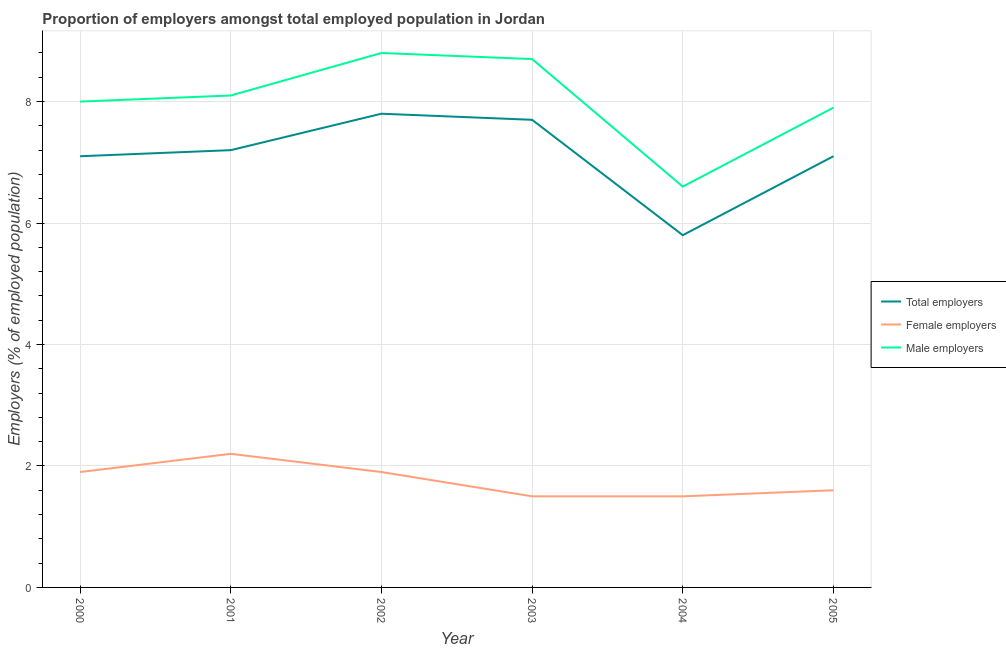Is the number of lines equal to the number of legend labels?
Ensure brevity in your answer.  Yes. What is the percentage of male employers in 2001?
Provide a short and direct response. 8.1. Across all years, what is the maximum percentage of male employers?
Offer a terse response. 8.8. Across all years, what is the minimum percentage of total employers?
Your answer should be very brief. 5.8. In which year was the percentage of total employers minimum?
Offer a very short reply. 2004. What is the total percentage of total employers in the graph?
Keep it short and to the point. 42.7. What is the difference between the percentage of total employers in 2000 and the percentage of male employers in 2003?
Ensure brevity in your answer.  -1.6. What is the average percentage of male employers per year?
Your response must be concise. 8.02. In the year 2004, what is the difference between the percentage of female employers and percentage of male employers?
Your answer should be very brief. -5.1. What is the ratio of the percentage of female employers in 2002 to that in 2003?
Give a very brief answer. 1.27. What is the difference between the highest and the second highest percentage of male employers?
Provide a short and direct response. 0.1. What is the difference between the highest and the lowest percentage of female employers?
Your response must be concise. 0.7. Is it the case that in every year, the sum of the percentage of total employers and percentage of female employers is greater than the percentage of male employers?
Offer a terse response. Yes. Does the percentage of total employers monotonically increase over the years?
Your response must be concise. No. Is the percentage of female employers strictly less than the percentage of total employers over the years?
Offer a terse response. Yes. How many lines are there?
Offer a very short reply. 3. Does the graph contain any zero values?
Your answer should be very brief. No. How many legend labels are there?
Ensure brevity in your answer.  3. What is the title of the graph?
Make the answer very short. Proportion of employers amongst total employed population in Jordan. What is the label or title of the X-axis?
Your answer should be very brief. Year. What is the label or title of the Y-axis?
Your answer should be very brief. Employers (% of employed population). What is the Employers (% of employed population) in Total employers in 2000?
Offer a terse response. 7.1. What is the Employers (% of employed population) of Female employers in 2000?
Offer a terse response. 1.9. What is the Employers (% of employed population) in Total employers in 2001?
Offer a very short reply. 7.2. What is the Employers (% of employed population) of Female employers in 2001?
Your response must be concise. 2.2. What is the Employers (% of employed population) in Male employers in 2001?
Give a very brief answer. 8.1. What is the Employers (% of employed population) of Total employers in 2002?
Your answer should be compact. 7.8. What is the Employers (% of employed population) in Female employers in 2002?
Provide a succinct answer. 1.9. What is the Employers (% of employed population) in Male employers in 2002?
Offer a terse response. 8.8. What is the Employers (% of employed population) in Total employers in 2003?
Your answer should be compact. 7.7. What is the Employers (% of employed population) of Male employers in 2003?
Provide a short and direct response. 8.7. What is the Employers (% of employed population) in Total employers in 2004?
Provide a succinct answer. 5.8. What is the Employers (% of employed population) in Male employers in 2004?
Your response must be concise. 6.6. What is the Employers (% of employed population) of Total employers in 2005?
Your answer should be compact. 7.1. What is the Employers (% of employed population) of Female employers in 2005?
Offer a very short reply. 1.6. What is the Employers (% of employed population) of Male employers in 2005?
Offer a terse response. 7.9. Across all years, what is the maximum Employers (% of employed population) of Total employers?
Offer a terse response. 7.8. Across all years, what is the maximum Employers (% of employed population) in Female employers?
Make the answer very short. 2.2. Across all years, what is the maximum Employers (% of employed population) of Male employers?
Provide a short and direct response. 8.8. Across all years, what is the minimum Employers (% of employed population) of Total employers?
Your answer should be very brief. 5.8. Across all years, what is the minimum Employers (% of employed population) in Female employers?
Ensure brevity in your answer.  1.5. Across all years, what is the minimum Employers (% of employed population) of Male employers?
Keep it short and to the point. 6.6. What is the total Employers (% of employed population) in Total employers in the graph?
Keep it short and to the point. 42.7. What is the total Employers (% of employed population) of Female employers in the graph?
Your answer should be very brief. 10.6. What is the total Employers (% of employed population) of Male employers in the graph?
Give a very brief answer. 48.1. What is the difference between the Employers (% of employed population) of Female employers in 2000 and that in 2001?
Your answer should be compact. -0.3. What is the difference between the Employers (% of employed population) in Male employers in 2000 and that in 2001?
Give a very brief answer. -0.1. What is the difference between the Employers (% of employed population) in Female employers in 2000 and that in 2002?
Ensure brevity in your answer.  0. What is the difference between the Employers (% of employed population) in Female employers in 2000 and that in 2003?
Provide a short and direct response. 0.4. What is the difference between the Employers (% of employed population) in Total employers in 2000 and that in 2004?
Provide a short and direct response. 1.3. What is the difference between the Employers (% of employed population) of Male employers in 2000 and that in 2004?
Provide a short and direct response. 1.4. What is the difference between the Employers (% of employed population) in Total employers in 2000 and that in 2005?
Offer a terse response. 0. What is the difference between the Employers (% of employed population) of Female employers in 2000 and that in 2005?
Give a very brief answer. 0.3. What is the difference between the Employers (% of employed population) of Male employers in 2000 and that in 2005?
Provide a succinct answer. 0.1. What is the difference between the Employers (% of employed population) of Total employers in 2001 and that in 2002?
Provide a succinct answer. -0.6. What is the difference between the Employers (% of employed population) of Female employers in 2001 and that in 2002?
Provide a short and direct response. 0.3. What is the difference between the Employers (% of employed population) of Total employers in 2001 and that in 2003?
Provide a short and direct response. -0.5. What is the difference between the Employers (% of employed population) of Female employers in 2001 and that in 2003?
Ensure brevity in your answer.  0.7. What is the difference between the Employers (% of employed population) of Total employers in 2001 and that in 2004?
Give a very brief answer. 1.4. What is the difference between the Employers (% of employed population) in Female employers in 2001 and that in 2004?
Give a very brief answer. 0.7. What is the difference between the Employers (% of employed population) of Total employers in 2001 and that in 2005?
Offer a very short reply. 0.1. What is the difference between the Employers (% of employed population) of Female employers in 2002 and that in 2003?
Offer a terse response. 0.4. What is the difference between the Employers (% of employed population) of Female employers in 2002 and that in 2004?
Keep it short and to the point. 0.4. What is the difference between the Employers (% of employed population) of Male employers in 2002 and that in 2004?
Give a very brief answer. 2.2. What is the difference between the Employers (% of employed population) of Female employers in 2002 and that in 2005?
Your response must be concise. 0.3. What is the difference between the Employers (% of employed population) of Total employers in 2003 and that in 2004?
Make the answer very short. 1.9. What is the difference between the Employers (% of employed population) in Male employers in 2003 and that in 2004?
Provide a short and direct response. 2.1. What is the difference between the Employers (% of employed population) of Male employers in 2003 and that in 2005?
Provide a short and direct response. 0.8. What is the difference between the Employers (% of employed population) in Total employers in 2000 and the Employers (% of employed population) in Male employers in 2001?
Offer a very short reply. -1. What is the difference between the Employers (% of employed population) of Total employers in 2000 and the Employers (% of employed population) of Female employers in 2002?
Ensure brevity in your answer.  5.2. What is the difference between the Employers (% of employed population) in Total employers in 2000 and the Employers (% of employed population) in Male employers in 2002?
Keep it short and to the point. -1.7. What is the difference between the Employers (% of employed population) of Female employers in 2000 and the Employers (% of employed population) of Male employers in 2002?
Offer a terse response. -6.9. What is the difference between the Employers (% of employed population) of Total employers in 2000 and the Employers (% of employed population) of Female employers in 2003?
Make the answer very short. 5.6. What is the difference between the Employers (% of employed population) in Total employers in 2000 and the Employers (% of employed population) in Female employers in 2004?
Make the answer very short. 5.6. What is the difference between the Employers (% of employed population) in Total employers in 2000 and the Employers (% of employed population) in Male employers in 2004?
Your response must be concise. 0.5. What is the difference between the Employers (% of employed population) in Total employers in 2000 and the Employers (% of employed population) in Female employers in 2005?
Your answer should be compact. 5.5. What is the difference between the Employers (% of employed population) of Female employers in 2000 and the Employers (% of employed population) of Male employers in 2005?
Make the answer very short. -6. What is the difference between the Employers (% of employed population) of Total employers in 2001 and the Employers (% of employed population) of Male employers in 2002?
Give a very brief answer. -1.6. What is the difference between the Employers (% of employed population) of Female employers in 2001 and the Employers (% of employed population) of Male employers in 2002?
Offer a very short reply. -6.6. What is the difference between the Employers (% of employed population) in Total employers in 2001 and the Employers (% of employed population) in Female employers in 2003?
Offer a terse response. 5.7. What is the difference between the Employers (% of employed population) of Total employers in 2001 and the Employers (% of employed population) of Male employers in 2003?
Offer a very short reply. -1.5. What is the difference between the Employers (% of employed population) in Total employers in 2001 and the Employers (% of employed population) in Female employers in 2004?
Ensure brevity in your answer.  5.7. What is the difference between the Employers (% of employed population) of Total employers in 2001 and the Employers (% of employed population) of Male employers in 2004?
Offer a very short reply. 0.6. What is the difference between the Employers (% of employed population) of Female employers in 2001 and the Employers (% of employed population) of Male employers in 2004?
Keep it short and to the point. -4.4. What is the difference between the Employers (% of employed population) in Total employers in 2001 and the Employers (% of employed population) in Male employers in 2005?
Provide a short and direct response. -0.7. What is the difference between the Employers (% of employed population) in Female employers in 2001 and the Employers (% of employed population) in Male employers in 2005?
Make the answer very short. -5.7. What is the difference between the Employers (% of employed population) of Total employers in 2002 and the Employers (% of employed population) of Female employers in 2003?
Your answer should be compact. 6.3. What is the difference between the Employers (% of employed population) of Female employers in 2002 and the Employers (% of employed population) of Male employers in 2003?
Provide a succinct answer. -6.8. What is the difference between the Employers (% of employed population) of Total employers in 2002 and the Employers (% of employed population) of Male employers in 2004?
Your response must be concise. 1.2. What is the difference between the Employers (% of employed population) of Female employers in 2002 and the Employers (% of employed population) of Male employers in 2005?
Offer a terse response. -6. What is the difference between the Employers (% of employed population) in Total employers in 2003 and the Employers (% of employed population) in Female employers in 2005?
Keep it short and to the point. 6.1. What is the difference between the Employers (% of employed population) in Total employers in 2003 and the Employers (% of employed population) in Male employers in 2005?
Make the answer very short. -0.2. What is the difference between the Employers (% of employed population) of Female employers in 2003 and the Employers (% of employed population) of Male employers in 2005?
Make the answer very short. -6.4. What is the difference between the Employers (% of employed population) of Total employers in 2004 and the Employers (% of employed population) of Male employers in 2005?
Ensure brevity in your answer.  -2.1. What is the average Employers (% of employed population) in Total employers per year?
Your answer should be very brief. 7.12. What is the average Employers (% of employed population) in Female employers per year?
Provide a succinct answer. 1.77. What is the average Employers (% of employed population) in Male employers per year?
Give a very brief answer. 8.02. In the year 2000, what is the difference between the Employers (% of employed population) in Total employers and Employers (% of employed population) in Female employers?
Keep it short and to the point. 5.2. In the year 2000, what is the difference between the Employers (% of employed population) of Total employers and Employers (% of employed population) of Male employers?
Make the answer very short. -0.9. In the year 2000, what is the difference between the Employers (% of employed population) of Female employers and Employers (% of employed population) of Male employers?
Your answer should be very brief. -6.1. In the year 2001, what is the difference between the Employers (% of employed population) in Total employers and Employers (% of employed population) in Male employers?
Provide a succinct answer. -0.9. In the year 2001, what is the difference between the Employers (% of employed population) of Female employers and Employers (% of employed population) of Male employers?
Provide a short and direct response. -5.9. In the year 2002, what is the difference between the Employers (% of employed population) in Female employers and Employers (% of employed population) in Male employers?
Provide a short and direct response. -6.9. In the year 2003, what is the difference between the Employers (% of employed population) of Total employers and Employers (% of employed population) of Female employers?
Give a very brief answer. 6.2. In the year 2004, what is the difference between the Employers (% of employed population) in Total employers and Employers (% of employed population) in Male employers?
Offer a terse response. -0.8. In the year 2004, what is the difference between the Employers (% of employed population) of Female employers and Employers (% of employed population) of Male employers?
Your answer should be very brief. -5.1. In the year 2005, what is the difference between the Employers (% of employed population) in Total employers and Employers (% of employed population) in Female employers?
Offer a very short reply. 5.5. What is the ratio of the Employers (% of employed population) in Total employers in 2000 to that in 2001?
Keep it short and to the point. 0.99. What is the ratio of the Employers (% of employed population) of Female employers in 2000 to that in 2001?
Make the answer very short. 0.86. What is the ratio of the Employers (% of employed population) in Male employers in 2000 to that in 2001?
Your response must be concise. 0.99. What is the ratio of the Employers (% of employed population) in Total employers in 2000 to that in 2002?
Provide a short and direct response. 0.91. What is the ratio of the Employers (% of employed population) of Male employers in 2000 to that in 2002?
Provide a short and direct response. 0.91. What is the ratio of the Employers (% of employed population) in Total employers in 2000 to that in 2003?
Give a very brief answer. 0.92. What is the ratio of the Employers (% of employed population) in Female employers in 2000 to that in 2003?
Your answer should be very brief. 1.27. What is the ratio of the Employers (% of employed population) in Male employers in 2000 to that in 2003?
Keep it short and to the point. 0.92. What is the ratio of the Employers (% of employed population) in Total employers in 2000 to that in 2004?
Make the answer very short. 1.22. What is the ratio of the Employers (% of employed population) in Female employers in 2000 to that in 2004?
Keep it short and to the point. 1.27. What is the ratio of the Employers (% of employed population) in Male employers in 2000 to that in 2004?
Offer a terse response. 1.21. What is the ratio of the Employers (% of employed population) of Total employers in 2000 to that in 2005?
Offer a very short reply. 1. What is the ratio of the Employers (% of employed population) of Female employers in 2000 to that in 2005?
Provide a succinct answer. 1.19. What is the ratio of the Employers (% of employed population) in Male employers in 2000 to that in 2005?
Keep it short and to the point. 1.01. What is the ratio of the Employers (% of employed population) in Total employers in 2001 to that in 2002?
Your answer should be compact. 0.92. What is the ratio of the Employers (% of employed population) of Female employers in 2001 to that in 2002?
Provide a short and direct response. 1.16. What is the ratio of the Employers (% of employed population) in Male employers in 2001 to that in 2002?
Your answer should be very brief. 0.92. What is the ratio of the Employers (% of employed population) in Total employers in 2001 to that in 2003?
Make the answer very short. 0.94. What is the ratio of the Employers (% of employed population) of Female employers in 2001 to that in 2003?
Give a very brief answer. 1.47. What is the ratio of the Employers (% of employed population) in Male employers in 2001 to that in 2003?
Keep it short and to the point. 0.93. What is the ratio of the Employers (% of employed population) in Total employers in 2001 to that in 2004?
Provide a succinct answer. 1.24. What is the ratio of the Employers (% of employed population) in Female employers in 2001 to that in 2004?
Your response must be concise. 1.47. What is the ratio of the Employers (% of employed population) in Male employers in 2001 to that in 2004?
Your response must be concise. 1.23. What is the ratio of the Employers (% of employed population) in Total employers in 2001 to that in 2005?
Provide a succinct answer. 1.01. What is the ratio of the Employers (% of employed population) of Female employers in 2001 to that in 2005?
Make the answer very short. 1.38. What is the ratio of the Employers (% of employed population) in Male employers in 2001 to that in 2005?
Provide a succinct answer. 1.03. What is the ratio of the Employers (% of employed population) in Total employers in 2002 to that in 2003?
Your response must be concise. 1.01. What is the ratio of the Employers (% of employed population) of Female employers in 2002 to that in 2003?
Your response must be concise. 1.27. What is the ratio of the Employers (% of employed population) of Male employers in 2002 to that in 2003?
Your response must be concise. 1.01. What is the ratio of the Employers (% of employed population) in Total employers in 2002 to that in 2004?
Offer a terse response. 1.34. What is the ratio of the Employers (% of employed population) in Female employers in 2002 to that in 2004?
Provide a succinct answer. 1.27. What is the ratio of the Employers (% of employed population) of Male employers in 2002 to that in 2004?
Provide a short and direct response. 1.33. What is the ratio of the Employers (% of employed population) of Total employers in 2002 to that in 2005?
Offer a terse response. 1.1. What is the ratio of the Employers (% of employed population) in Female employers in 2002 to that in 2005?
Your response must be concise. 1.19. What is the ratio of the Employers (% of employed population) of Male employers in 2002 to that in 2005?
Provide a short and direct response. 1.11. What is the ratio of the Employers (% of employed population) of Total employers in 2003 to that in 2004?
Ensure brevity in your answer.  1.33. What is the ratio of the Employers (% of employed population) in Male employers in 2003 to that in 2004?
Give a very brief answer. 1.32. What is the ratio of the Employers (% of employed population) of Total employers in 2003 to that in 2005?
Offer a terse response. 1.08. What is the ratio of the Employers (% of employed population) of Female employers in 2003 to that in 2005?
Provide a short and direct response. 0.94. What is the ratio of the Employers (% of employed population) in Male employers in 2003 to that in 2005?
Provide a short and direct response. 1.1. What is the ratio of the Employers (% of employed population) in Total employers in 2004 to that in 2005?
Provide a short and direct response. 0.82. What is the ratio of the Employers (% of employed population) in Female employers in 2004 to that in 2005?
Make the answer very short. 0.94. What is the ratio of the Employers (% of employed population) of Male employers in 2004 to that in 2005?
Offer a very short reply. 0.84. What is the difference between the highest and the second highest Employers (% of employed population) of Total employers?
Provide a succinct answer. 0.1. What is the difference between the highest and the second highest Employers (% of employed population) in Male employers?
Your answer should be compact. 0.1. What is the difference between the highest and the lowest Employers (% of employed population) in Female employers?
Offer a terse response. 0.7. What is the difference between the highest and the lowest Employers (% of employed population) of Male employers?
Offer a very short reply. 2.2. 